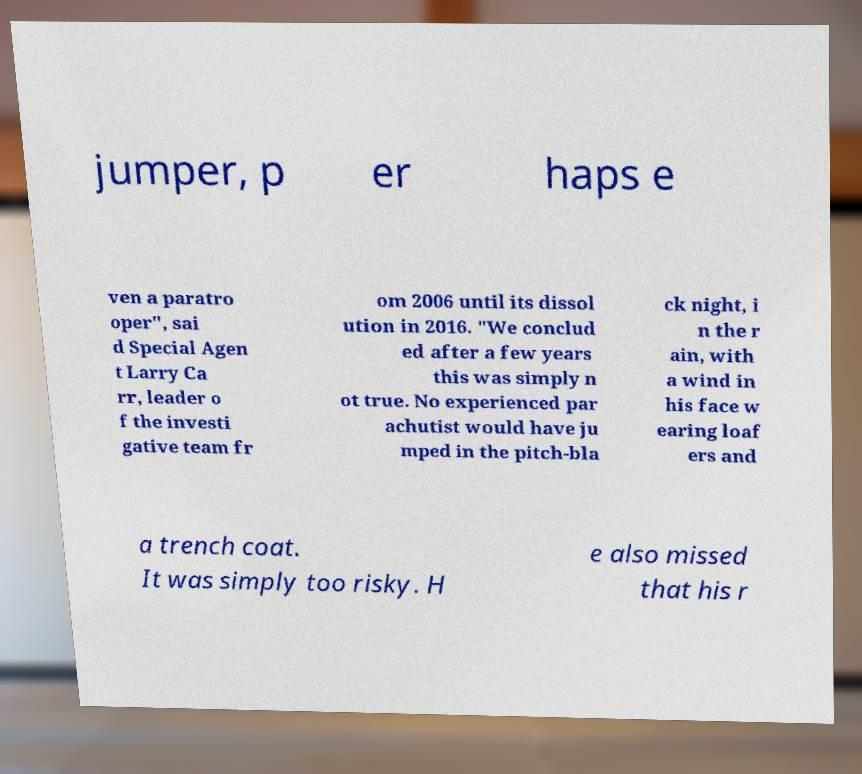Can you accurately transcribe the text from the provided image for me? jumper, p er haps e ven a paratro oper", sai d Special Agen t Larry Ca rr, leader o f the investi gative team fr om 2006 until its dissol ution in 2016. "We conclud ed after a few years this was simply n ot true. No experienced par achutist would have ju mped in the pitch-bla ck night, i n the r ain, with a wind in his face w earing loaf ers and a trench coat. It was simply too risky. H e also missed that his r 